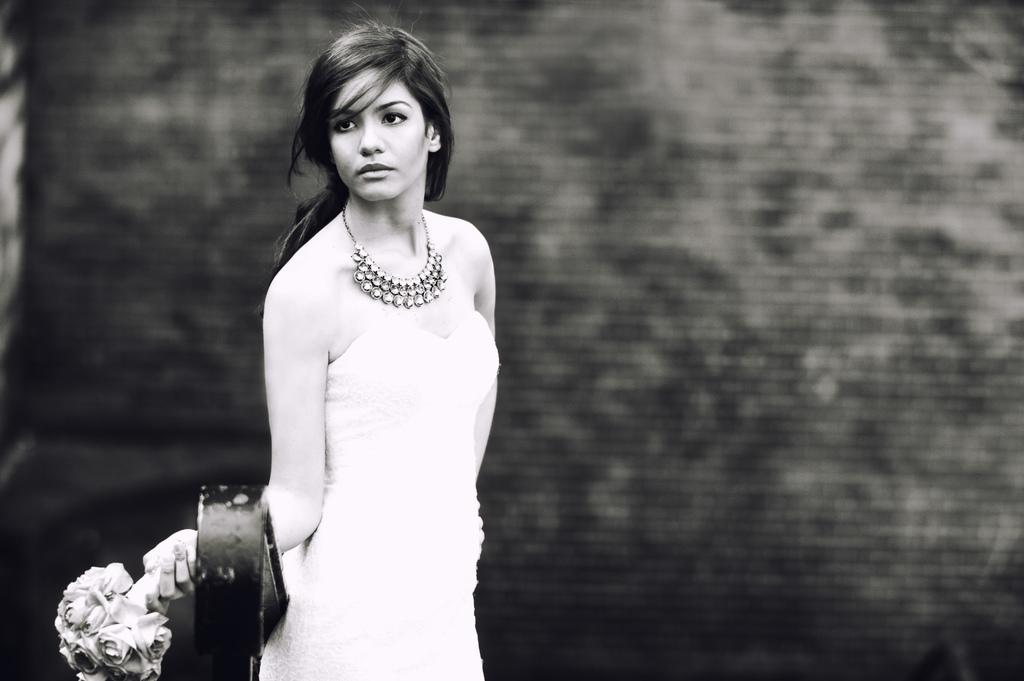What is the color scheme of the image? The image is black and white. Who is present in the image? There is a woman in the image. What is the woman doing in the image? The woman is standing in the image. What is the woman holding in the image? The woman is holding a bouquet in the image. What is the condition of the woman in the image? The provided facts do not mention any specific condition of the woman. --- Facts: 1. There is a car in the image. 2. The car is red. 3. The car has four doors. 4. The car is parked on the street. Absurd Topics: unicorn, rainbow, stars Conversation: What is the main subject in the image? There is a car in the image. What color is the car? The car is red. How many doors does the car have? The car has four doors. Where is the car located in the image? The car is parked on the street. Reasoning: Let's think step by step in order to produce the conversation. We start by identifying the main subject of the image, which is the car. Then, we describe specific features of the car, such as its color and the number of doors it has. Finally, we describe the location of the car in the image, which is parked on the street. Absurd Question/Answer: How many unicorns can be seen grazing on the side of the street in the image? There are no unicorns visible in the image. --- Facts: 1. There is a group of people in the image. 2. The people are wearing hats. 3. The people are holding umbrellas. 4. The people are standing in front of a building. Absurd Topics: elephants, parachutes, fireworks Conversation: What is the main subject of the image? The main subject of the image is a group of people. What are the people wearing in the image? The people are wearing hats in the image. What are the people holding in the image? The people are holding umbrellas in the image. Where are the people standing in the image? The people are standing in front of a building in the image. Reasoning: Let's think step by step in order to produce the conversation. We start by identifying the main subject of the image, which is the group of people. Then, we describe specific features of the people, such as their hats and umbrellas. Finally, we describe the location of the people in the image, which is in front of a building. Absurd Question/Answer: How many elephants can be seen flying with parachutes in the image? There are no elephants or parachutes present in 